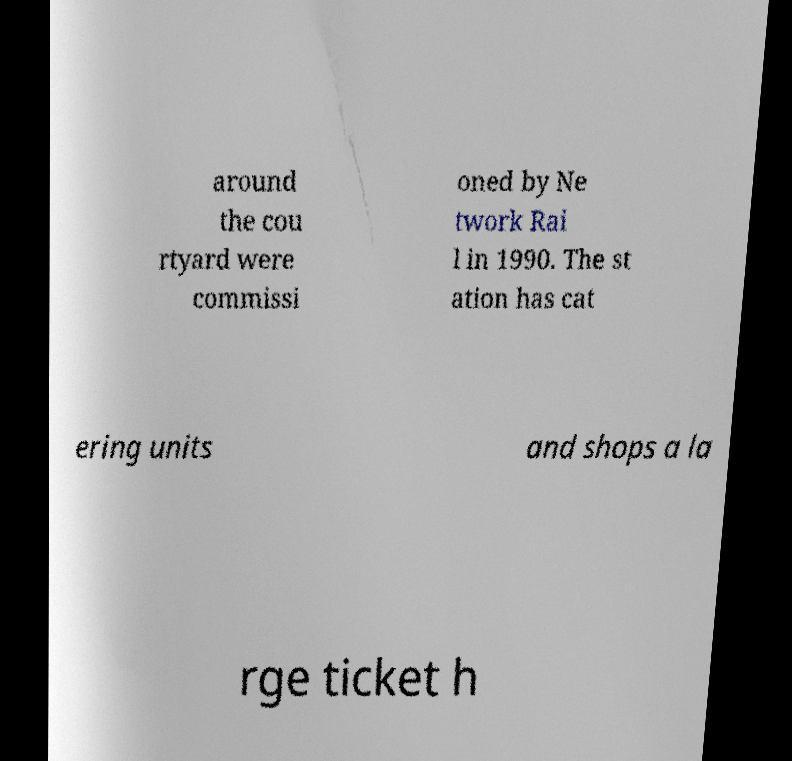I need the written content from this picture converted into text. Can you do that? around the cou rtyard were commissi oned by Ne twork Rai l in 1990. The st ation has cat ering units and shops a la rge ticket h 